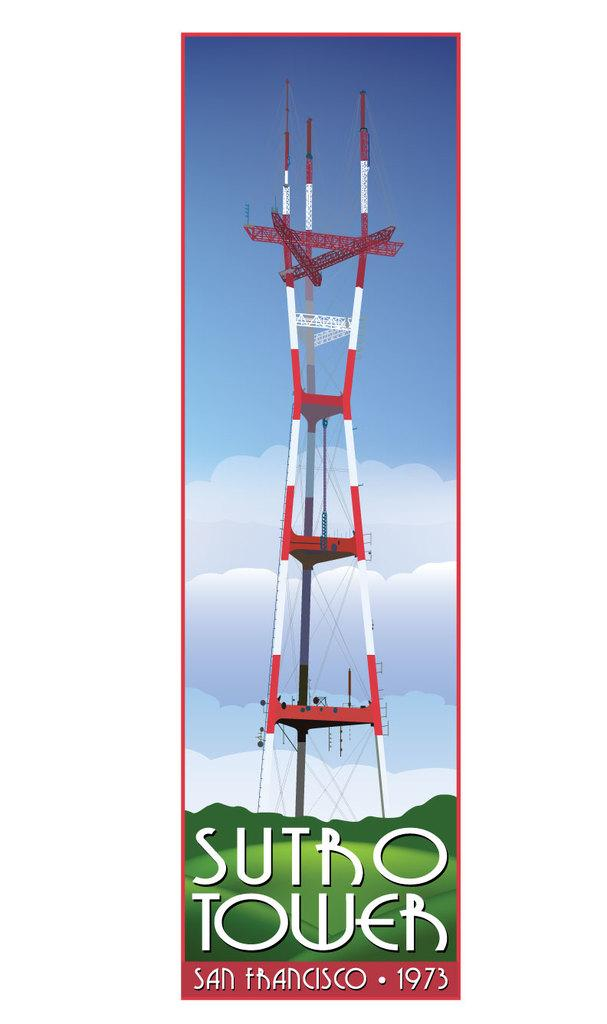<image>
Render a clear and concise summary of the photo. a poster for Sutro Tower in San Francisco 1973 